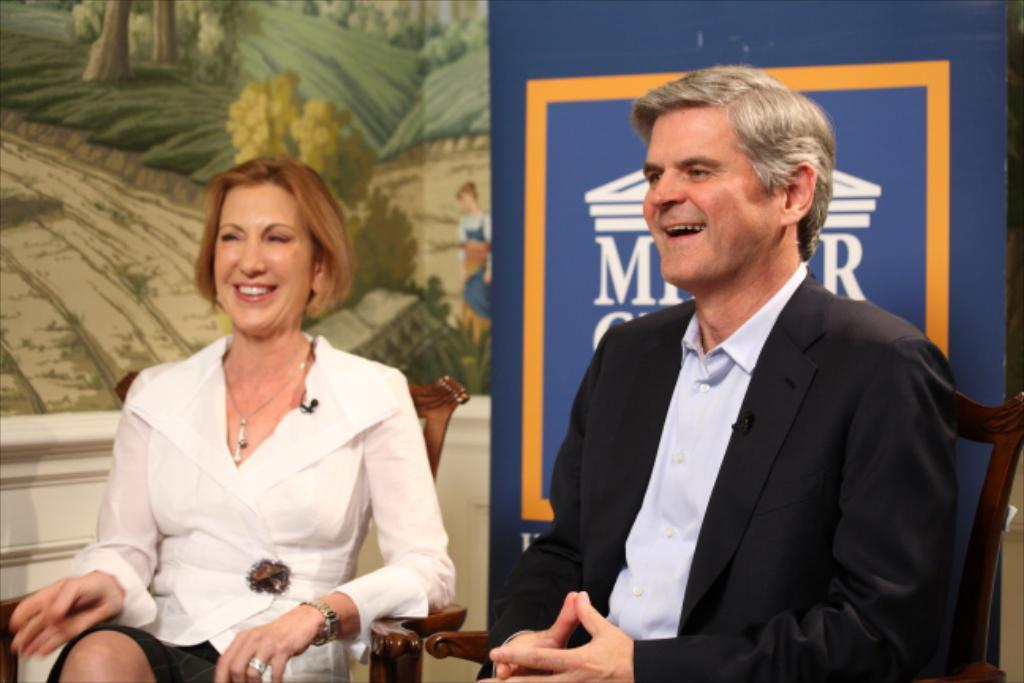How many people are in the image? There are two persons in the image. What are the persons doing in the image? The persons are sitting on chairs. What can be seen behind the persons in the image? There is a banner with text in the image, and it is located at the back of the persons. What other decorative element is present in the image? There is a wall with a painting in the image. What type of grape is being used as a prop in the image? There is no grape present in the image. What act are the persons performing in the image? The image does not depict a specific act or performance; it simply shows two persons sitting on chairs. 